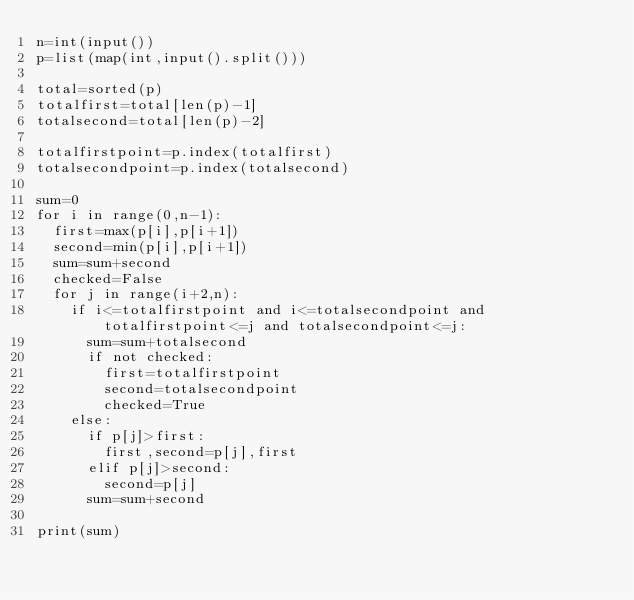Convert code to text. <code><loc_0><loc_0><loc_500><loc_500><_Python_>n=int(input())
p=list(map(int,input().split()))

total=sorted(p)
totalfirst=total[len(p)-1]
totalsecond=total[len(p)-2]

totalfirstpoint=p.index(totalfirst)
totalsecondpoint=p.index(totalsecond)

sum=0
for i in range(0,n-1):
  first=max(p[i],p[i+1])
  second=min(p[i],p[i+1])
  sum=sum+second
  checked=False
  for j in range(i+2,n):
    if i<=totalfirstpoint and i<=totalsecondpoint and totalfirstpoint<=j and totalsecondpoint<=j:
      sum=sum+totalsecond
      if not checked:
        first=totalfirstpoint
        second=totalsecondpoint
        checked=True
    else:
      if p[j]>first:
        first,second=p[j],first
      elif p[j]>second:
        second=p[j]
      sum=sum+second

print(sum)</code> 